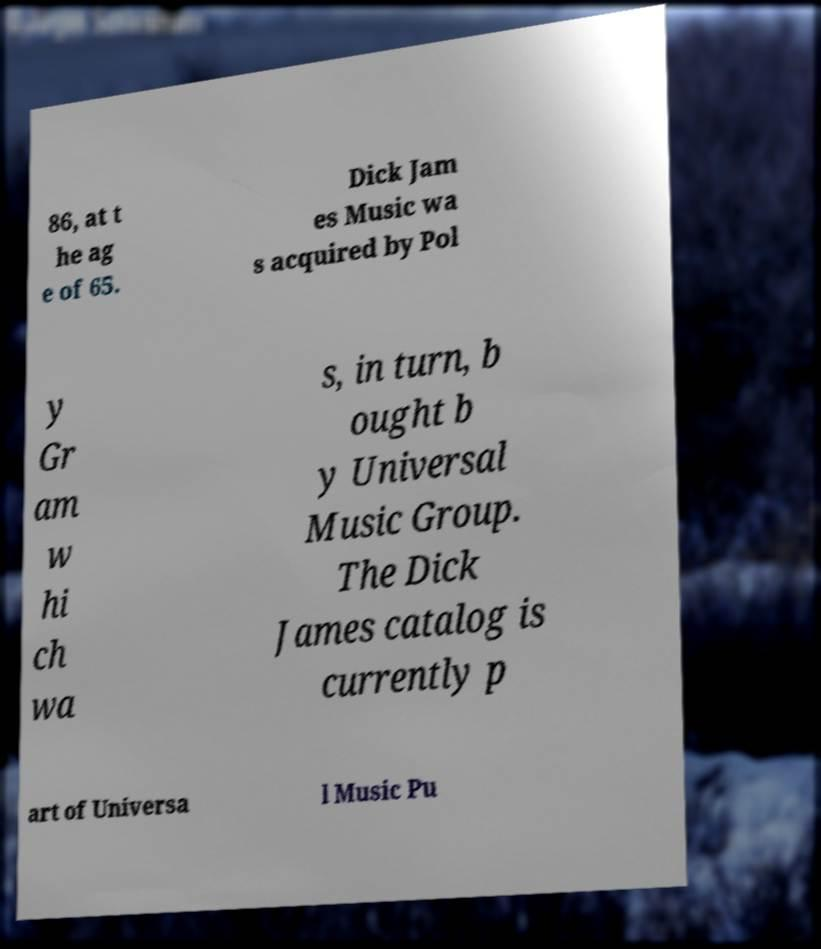Could you extract and type out the text from this image? 86, at t he ag e of 65. Dick Jam es Music wa s acquired by Pol y Gr am w hi ch wa s, in turn, b ought b y Universal Music Group. The Dick James catalog is currently p art of Universa l Music Pu 